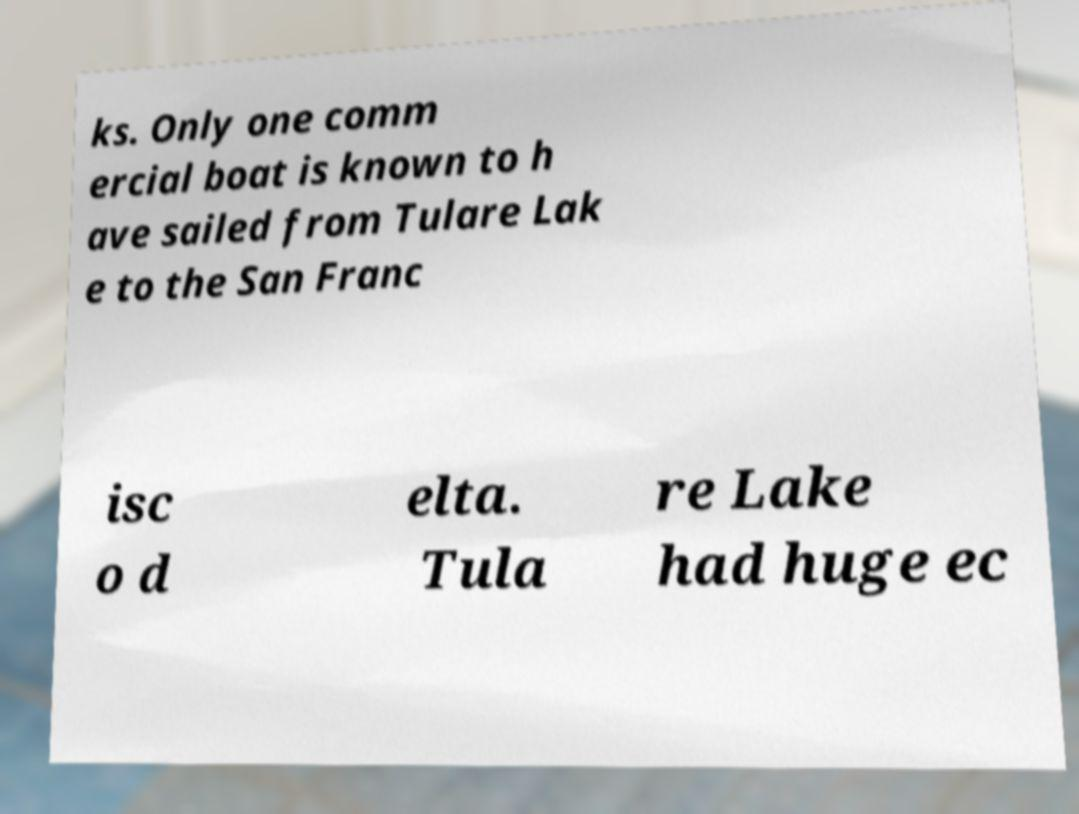For documentation purposes, I need the text within this image transcribed. Could you provide that? ks. Only one comm ercial boat is known to h ave sailed from Tulare Lak e to the San Franc isc o d elta. Tula re Lake had huge ec 